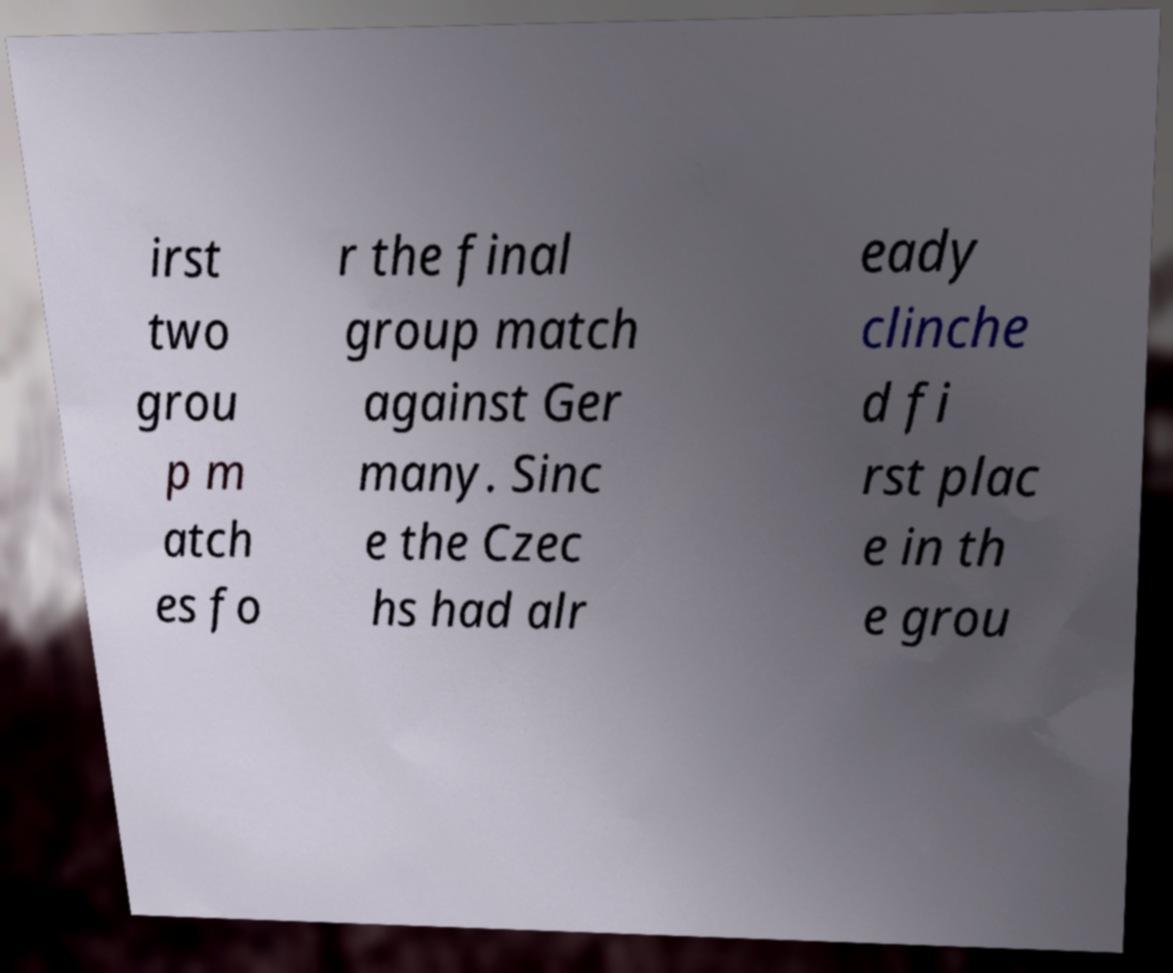Could you assist in decoding the text presented in this image and type it out clearly? irst two grou p m atch es fo r the final group match against Ger many. Sinc e the Czec hs had alr eady clinche d fi rst plac e in th e grou 